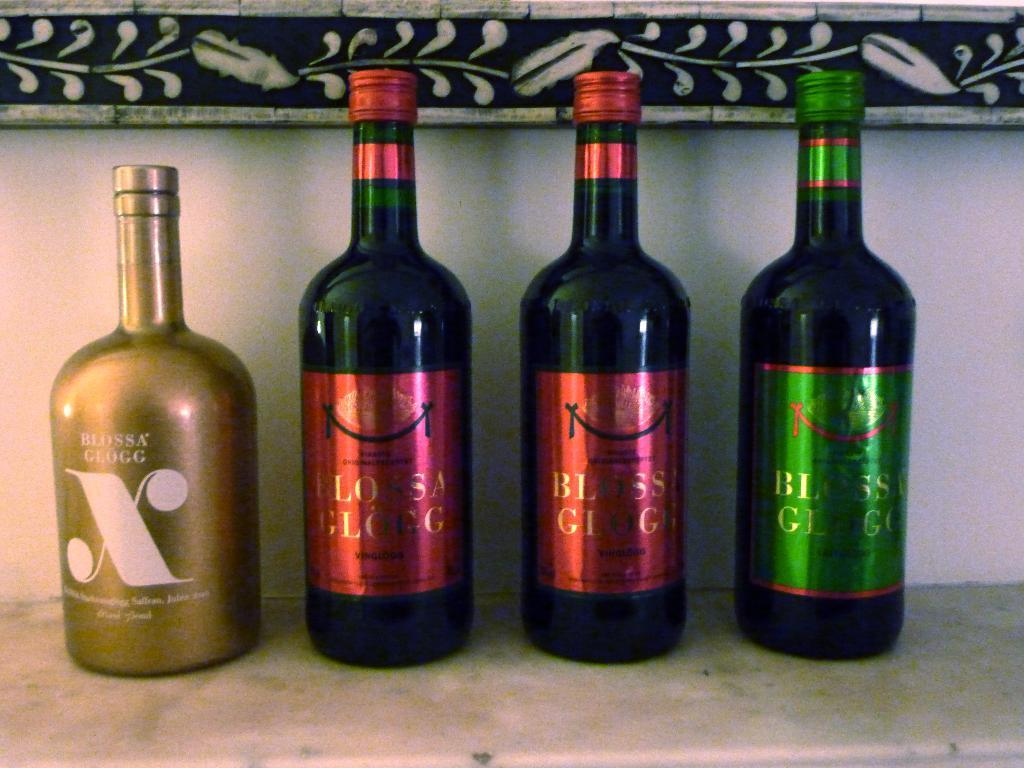Provide a one-sentence caption for the provided image. The wine in the golden bottle is from Blossa Glogg. 